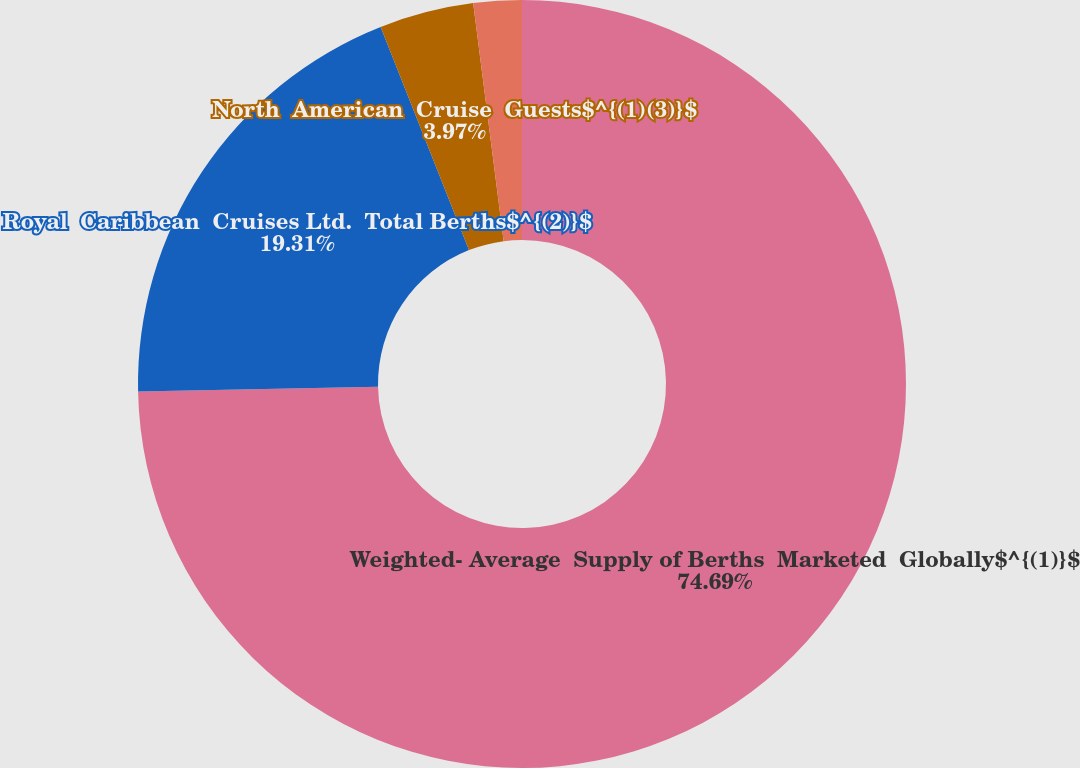<chart> <loc_0><loc_0><loc_500><loc_500><pie_chart><fcel>Weighted- Average  Supply of Berths  Marketed  Globally$^{(1)}$<fcel>Royal  Caribbean  Cruises Ltd.  Total Berths$^{(2)}$<fcel>North  American  Cruise  Guests$^{(1)(3)}$<fcel>European  Cruise  Guests$^{(1)(4)}$<nl><fcel>74.69%<fcel>19.31%<fcel>3.97%<fcel>2.03%<nl></chart> 